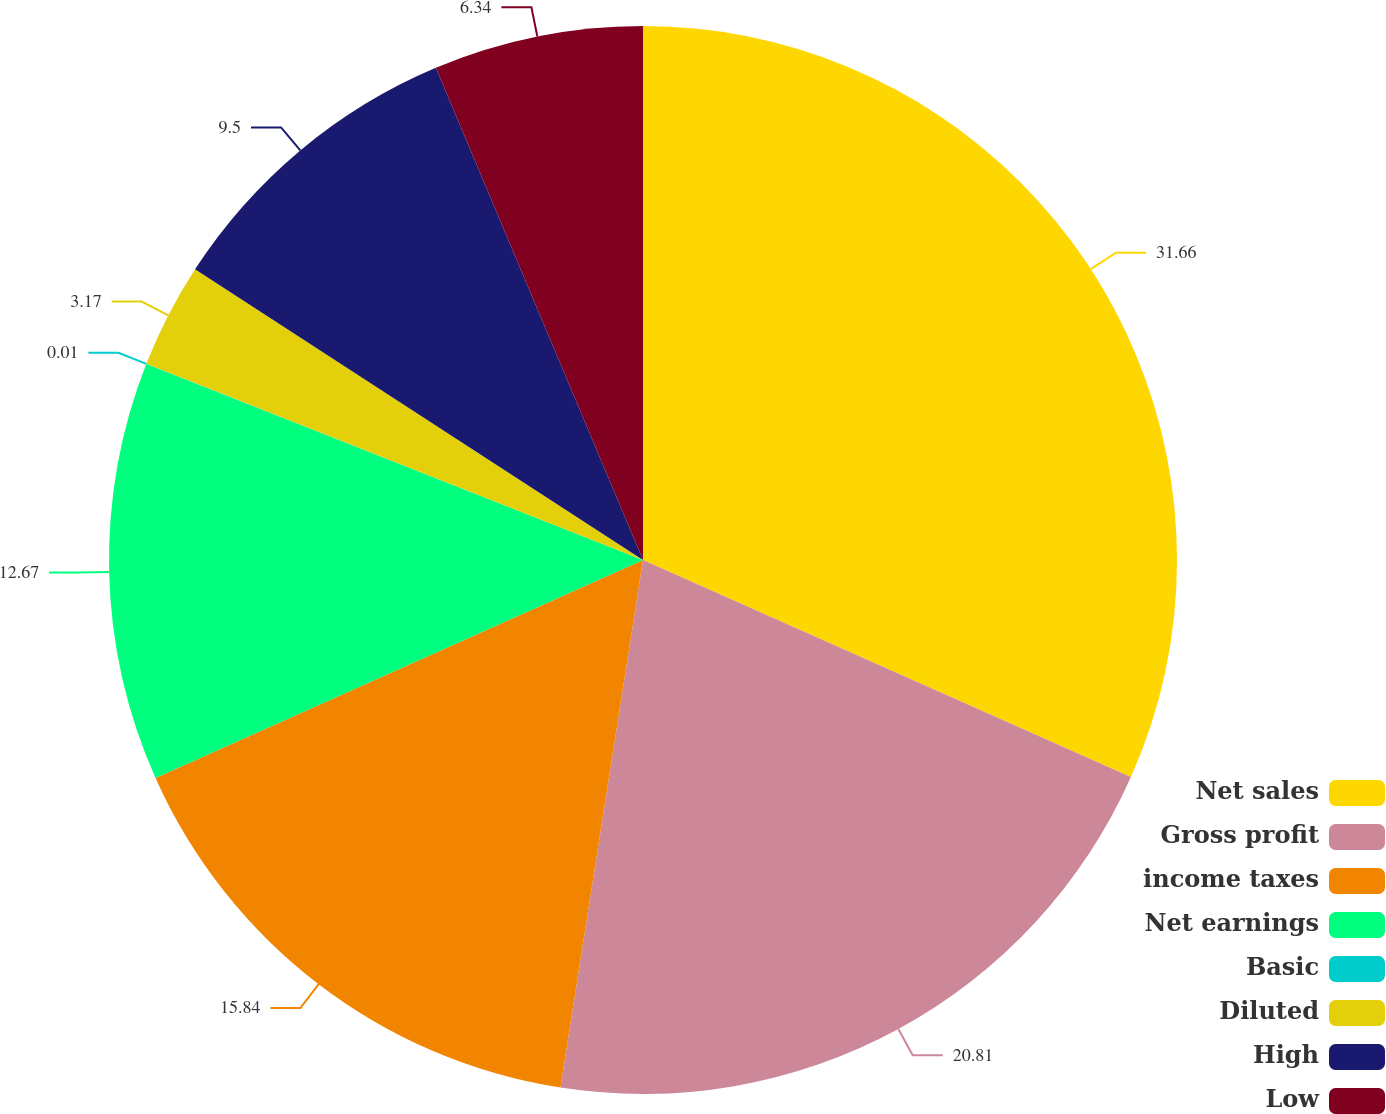<chart> <loc_0><loc_0><loc_500><loc_500><pie_chart><fcel>Net sales<fcel>Gross profit<fcel>income taxes<fcel>Net earnings<fcel>Basic<fcel>Diluted<fcel>High<fcel>Low<nl><fcel>31.66%<fcel>20.81%<fcel>15.84%<fcel>12.67%<fcel>0.01%<fcel>3.17%<fcel>9.5%<fcel>6.34%<nl></chart> 